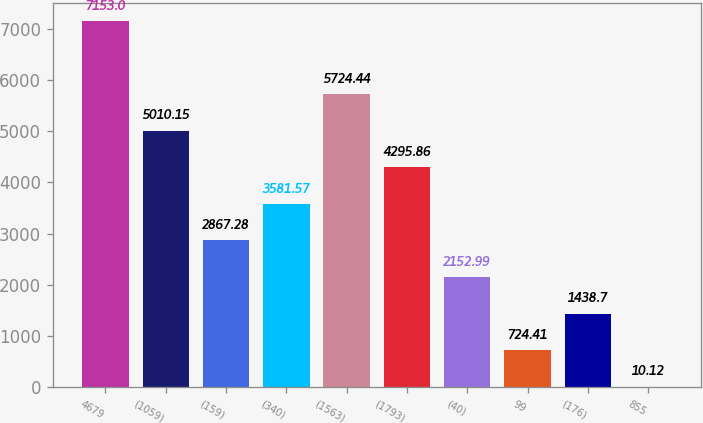Convert chart. <chart><loc_0><loc_0><loc_500><loc_500><bar_chart><fcel>4679<fcel>(1059)<fcel>(159)<fcel>(340)<fcel>(1563)<fcel>(1793)<fcel>(40)<fcel>99<fcel>(176)<fcel>855<nl><fcel>7153<fcel>5010.15<fcel>2867.28<fcel>3581.57<fcel>5724.44<fcel>4295.86<fcel>2152.99<fcel>724.41<fcel>1438.7<fcel>10.12<nl></chart> 